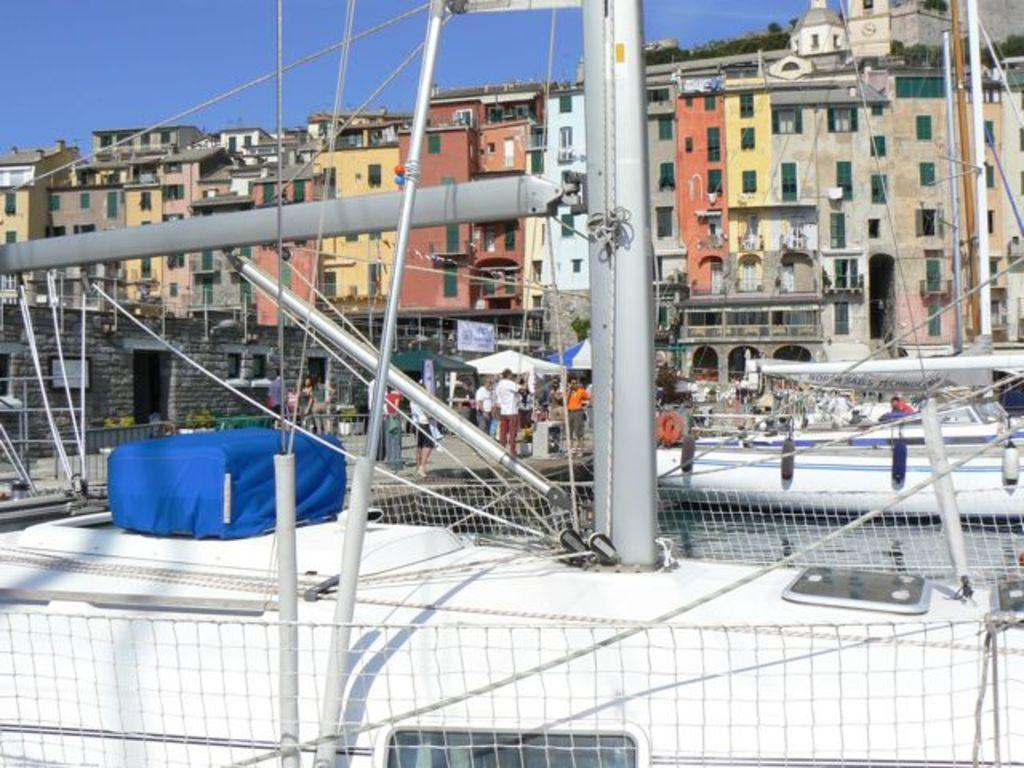What can be seen in the foreground of the image? In the foreground of the image, there are rods, wires, and other objects. Can you describe the people in the image? The people are behind the rods in the image. What structures are visible behind the rods? There are tents behind the rods, and buildings in the background of the image. What is the average income of the people playing volleyball in the image? There is no indication of people playing volleyball in the image, so we cannot determine their average income. 